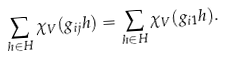Convert formula to latex. <formula><loc_0><loc_0><loc_500><loc_500>\sum _ { h \in H } \chi _ { V } ( g _ { i j } h ) = \sum _ { h \in H } \chi _ { V } ( g _ { i 1 } h ) .</formula> 